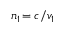<formula> <loc_0><loc_0><loc_500><loc_500>n _ { 1 \, } = c / v _ { 1 }</formula> 